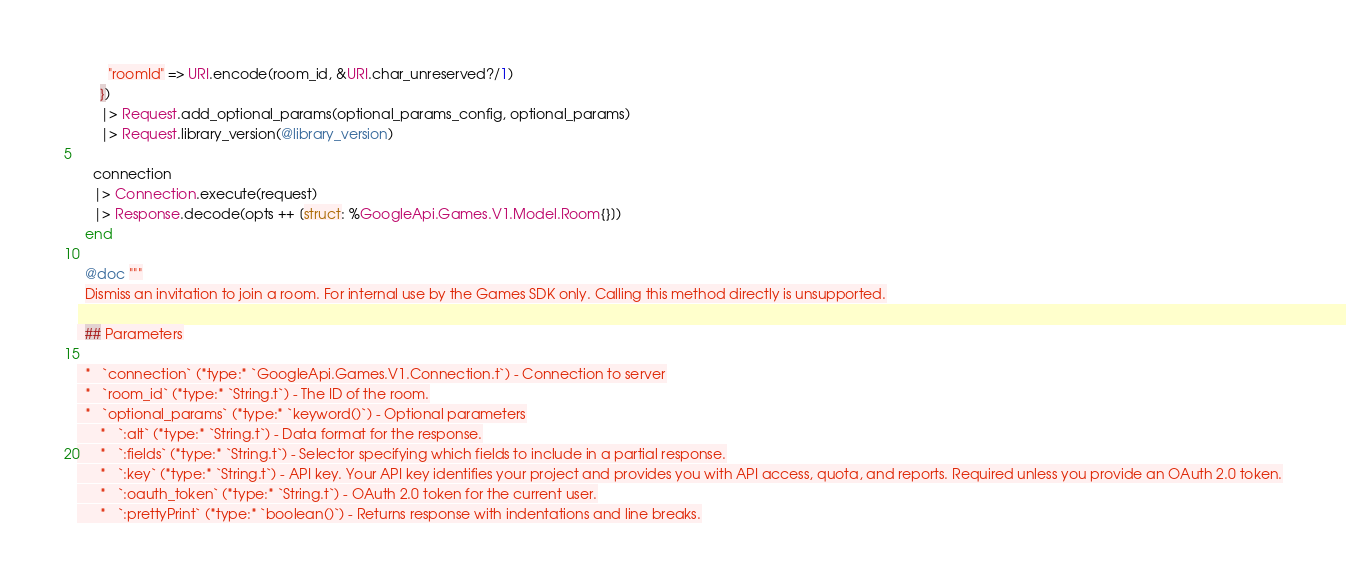<code> <loc_0><loc_0><loc_500><loc_500><_Elixir_>        "roomId" => URI.encode(room_id, &URI.char_unreserved?/1)
      })
      |> Request.add_optional_params(optional_params_config, optional_params)
      |> Request.library_version(@library_version)

    connection
    |> Connection.execute(request)
    |> Response.decode(opts ++ [struct: %GoogleApi.Games.V1.Model.Room{}])
  end

  @doc """
  Dismiss an invitation to join a room. For internal use by the Games SDK only. Calling this method directly is unsupported.

  ## Parameters

  *   `connection` (*type:* `GoogleApi.Games.V1.Connection.t`) - Connection to server
  *   `room_id` (*type:* `String.t`) - The ID of the room.
  *   `optional_params` (*type:* `keyword()`) - Optional parameters
      *   `:alt` (*type:* `String.t`) - Data format for the response.
      *   `:fields` (*type:* `String.t`) - Selector specifying which fields to include in a partial response.
      *   `:key` (*type:* `String.t`) - API key. Your API key identifies your project and provides you with API access, quota, and reports. Required unless you provide an OAuth 2.0 token.
      *   `:oauth_token` (*type:* `String.t`) - OAuth 2.0 token for the current user.
      *   `:prettyPrint` (*type:* `boolean()`) - Returns response with indentations and line breaks.</code> 